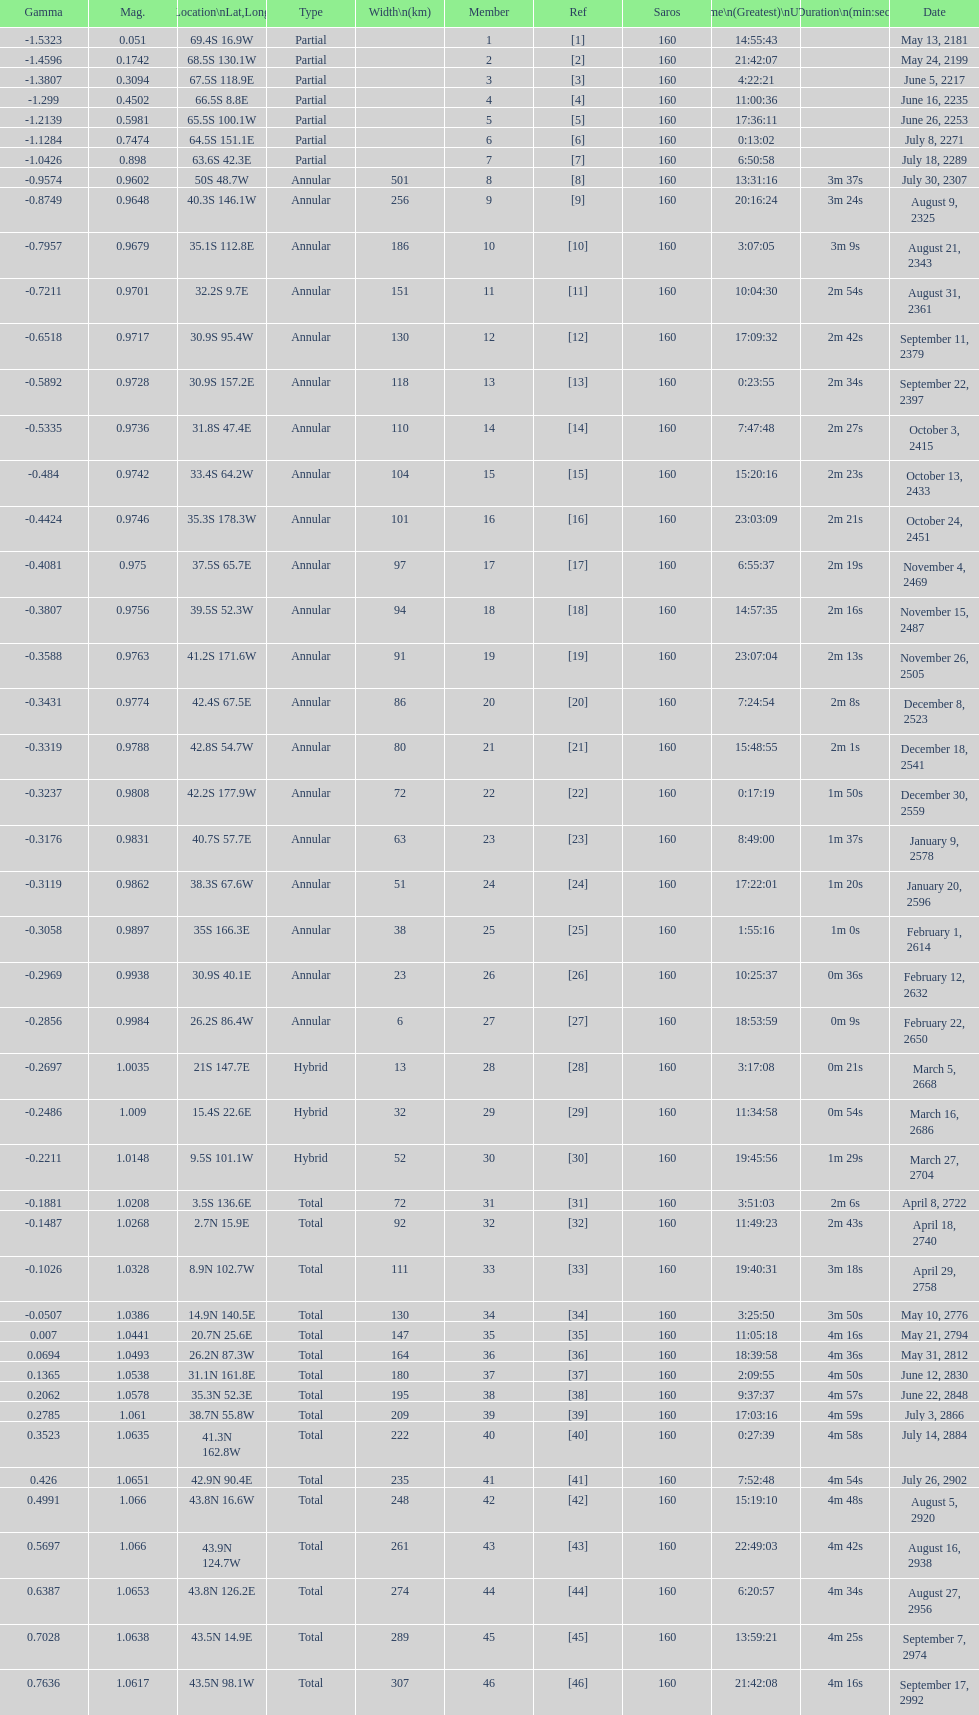How long did 18 last? 2m 16s. 